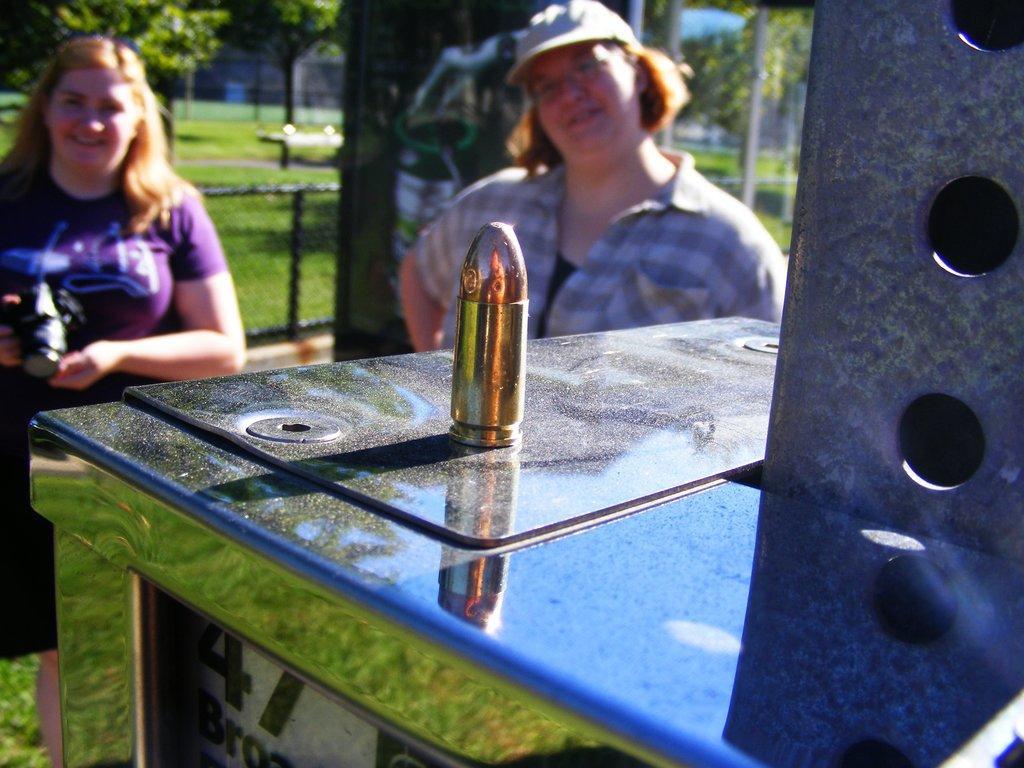Please provide a concise description of this image. In the image we can see there is a bullet kept on the table and there are women sitting on the chair. Behind there is ground covered with grass and there are trees. Background of the image is blurred. 